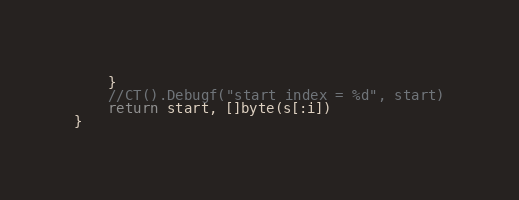Convert code to text. <code><loc_0><loc_0><loc_500><loc_500><_Go_>	}
	//CT().Debugf("start index = %d", start)
	return start, []byte(s[:i])
}
</code> 